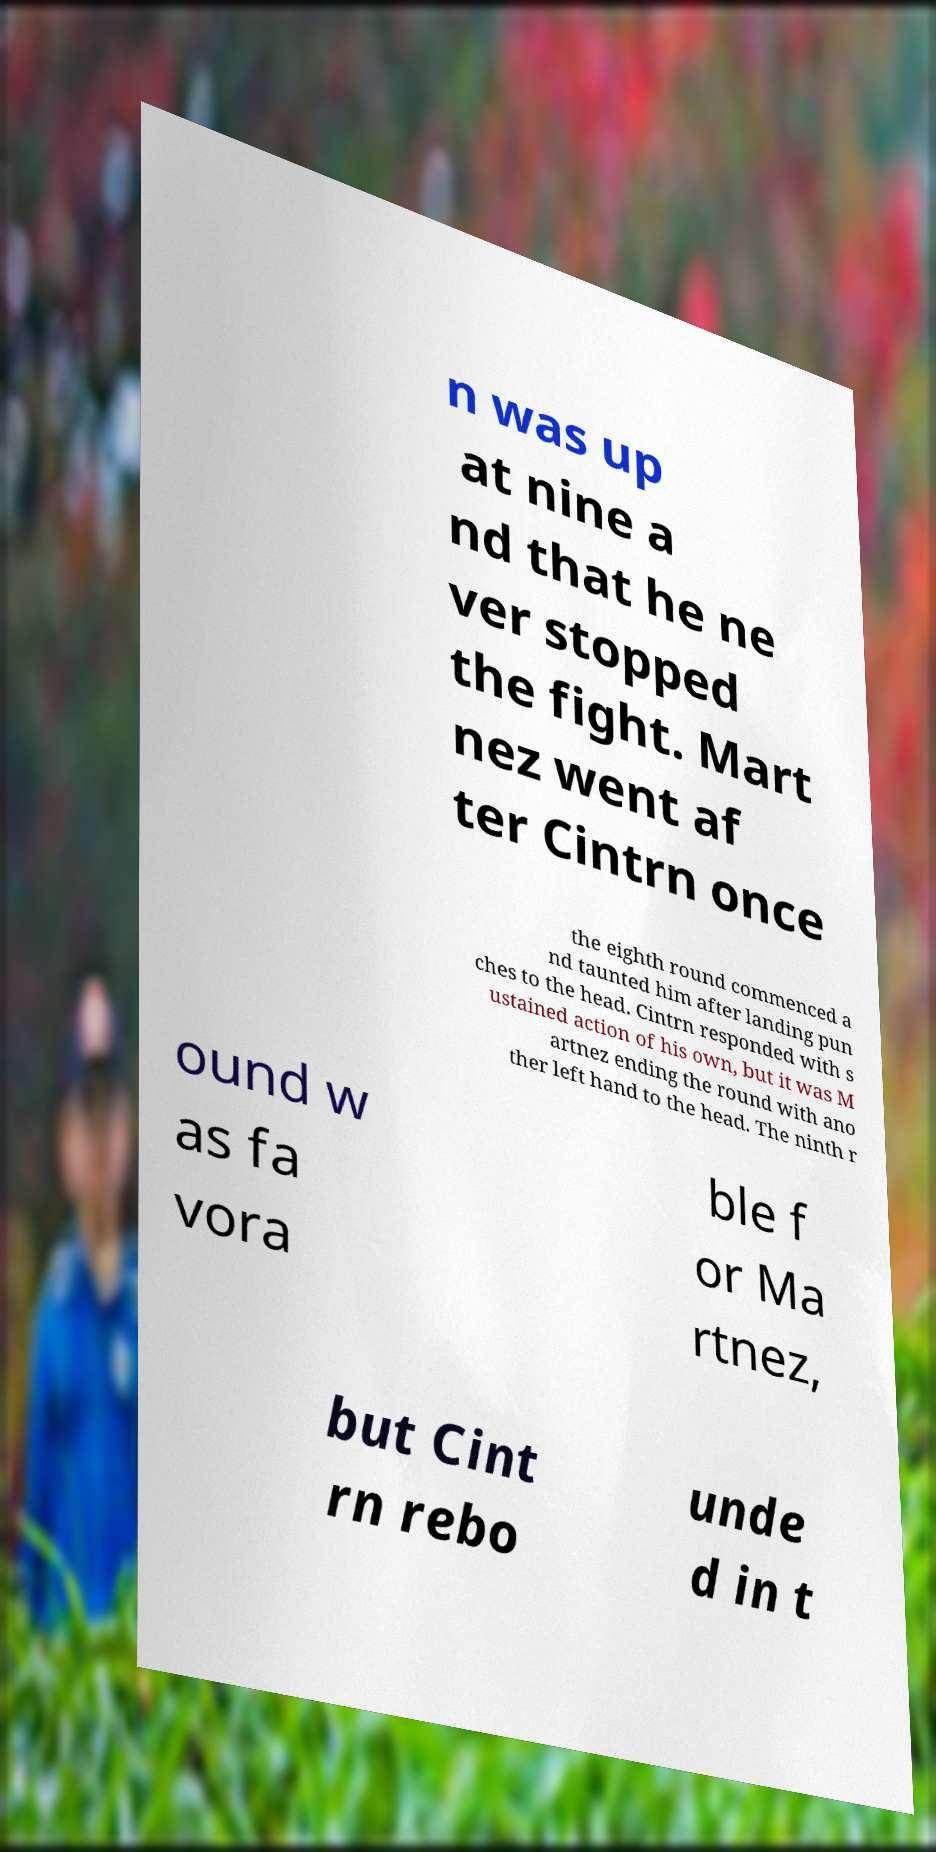Could you extract and type out the text from this image? n was up at nine a nd that he ne ver stopped the fight. Mart nez went af ter Cintrn once the eighth round commenced a nd taunted him after landing pun ches to the head. Cintrn responded with s ustained action of his own, but it was M artnez ending the round with ano ther left hand to the head. The ninth r ound w as fa vora ble f or Ma rtnez, but Cint rn rebo unde d in t 